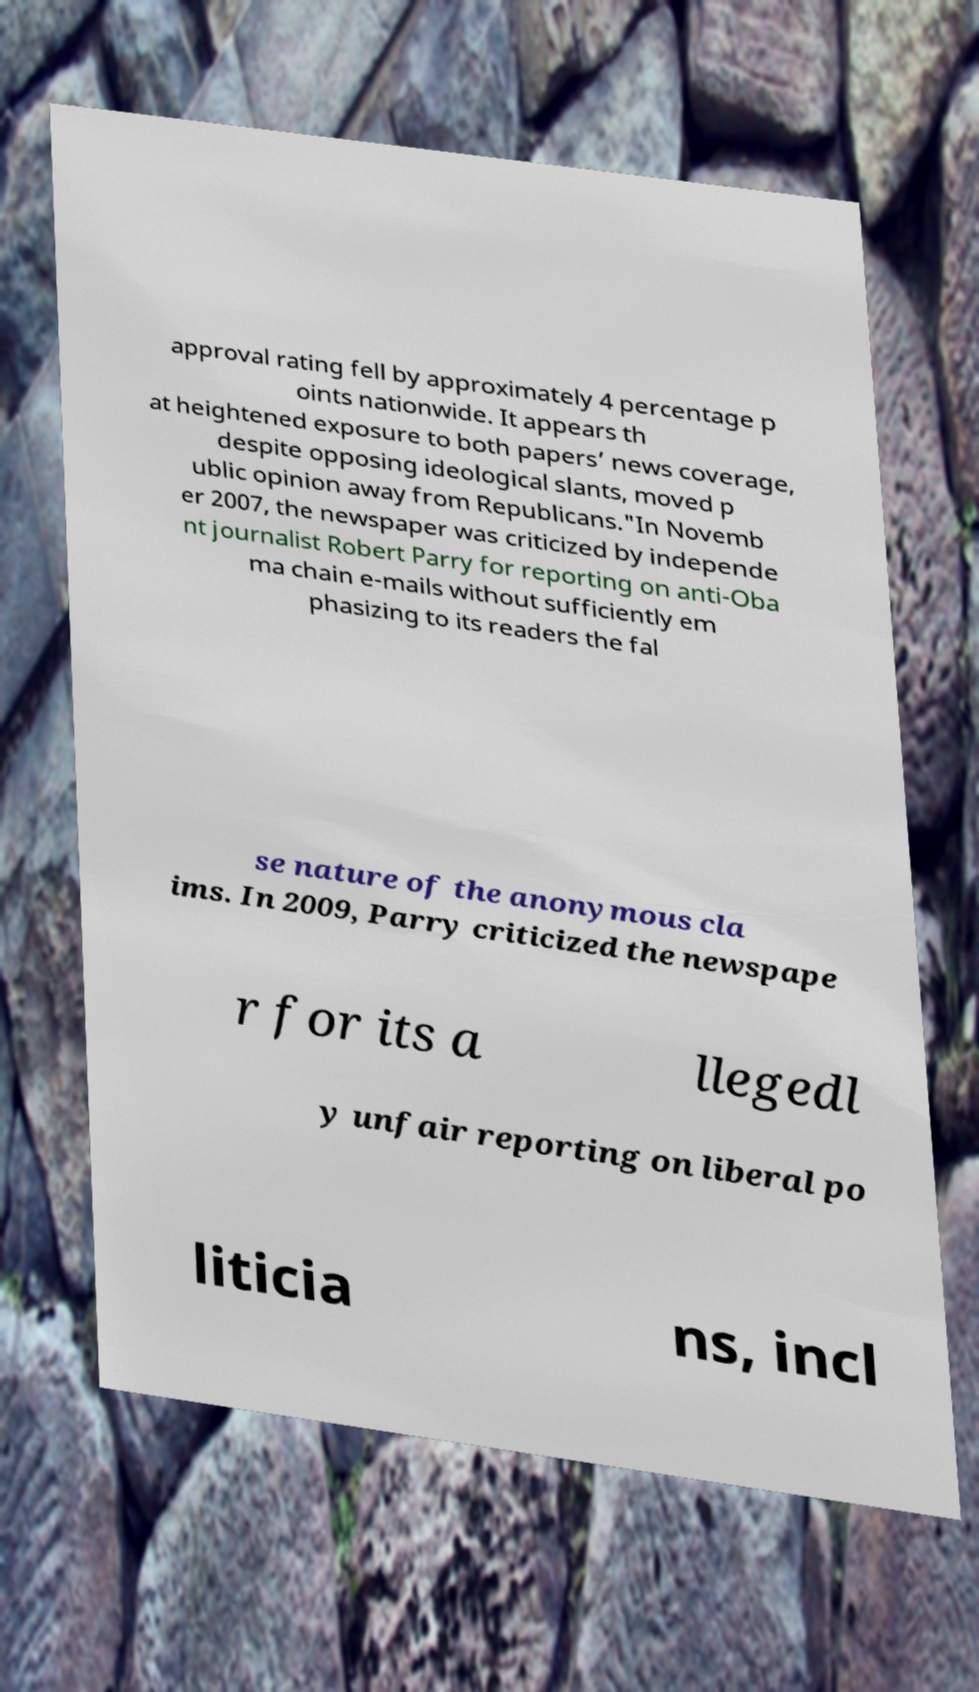Please read and relay the text visible in this image. What does it say? approval rating fell by approximately 4 percentage p oints nationwide. It appears th at heightened exposure to both papers’ news coverage, despite opposing ideological slants, moved p ublic opinion away from Republicans."In Novemb er 2007, the newspaper was criticized by independe nt journalist Robert Parry for reporting on anti-Oba ma chain e-mails without sufficiently em phasizing to its readers the fal se nature of the anonymous cla ims. In 2009, Parry criticized the newspape r for its a llegedl y unfair reporting on liberal po liticia ns, incl 